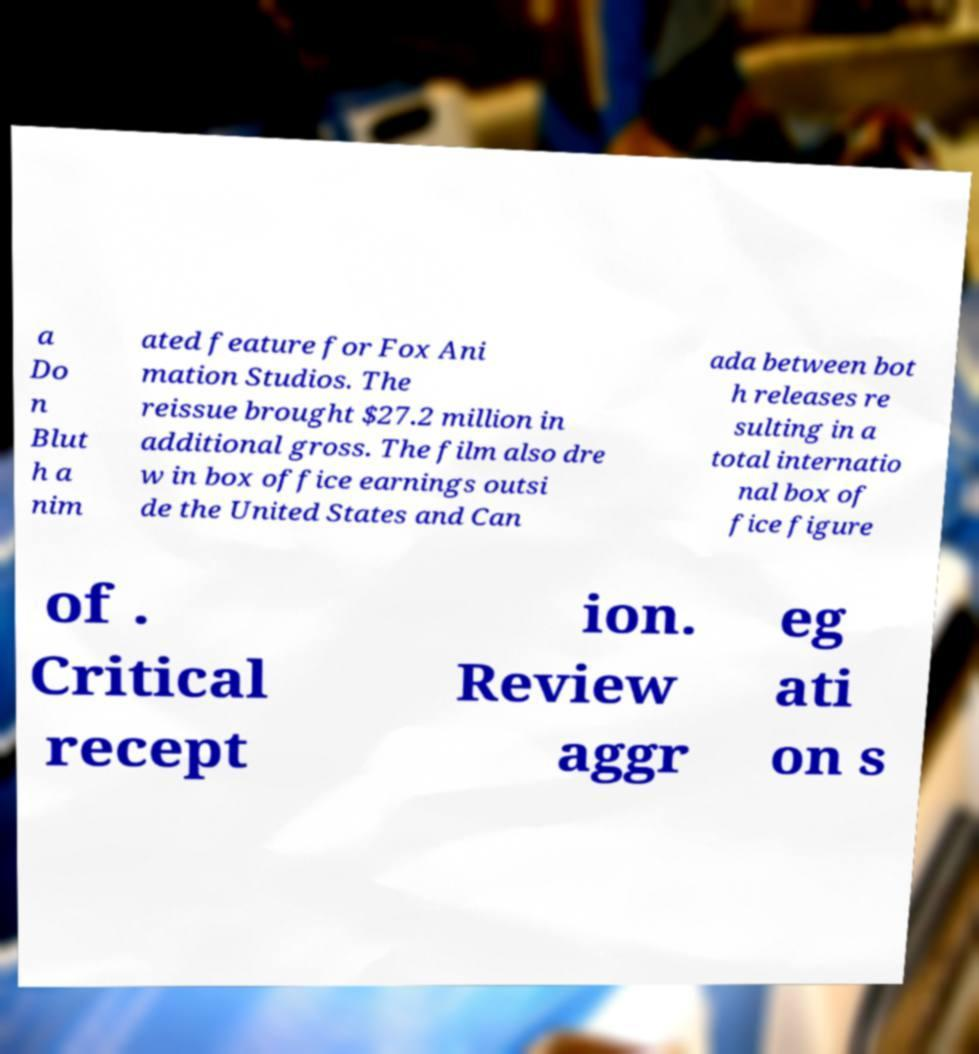Please read and relay the text visible in this image. What does it say? a Do n Blut h a nim ated feature for Fox Ani mation Studios. The reissue brought $27.2 million in additional gross. The film also dre w in box office earnings outsi de the United States and Can ada between bot h releases re sulting in a total internatio nal box of fice figure of . Critical recept ion. Review aggr eg ati on s 